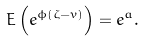Convert formula to latex. <formula><loc_0><loc_0><loc_500><loc_500>E \left ( e ^ { \phi ( \zeta - v ) } \right ) = e ^ { a } .</formula> 